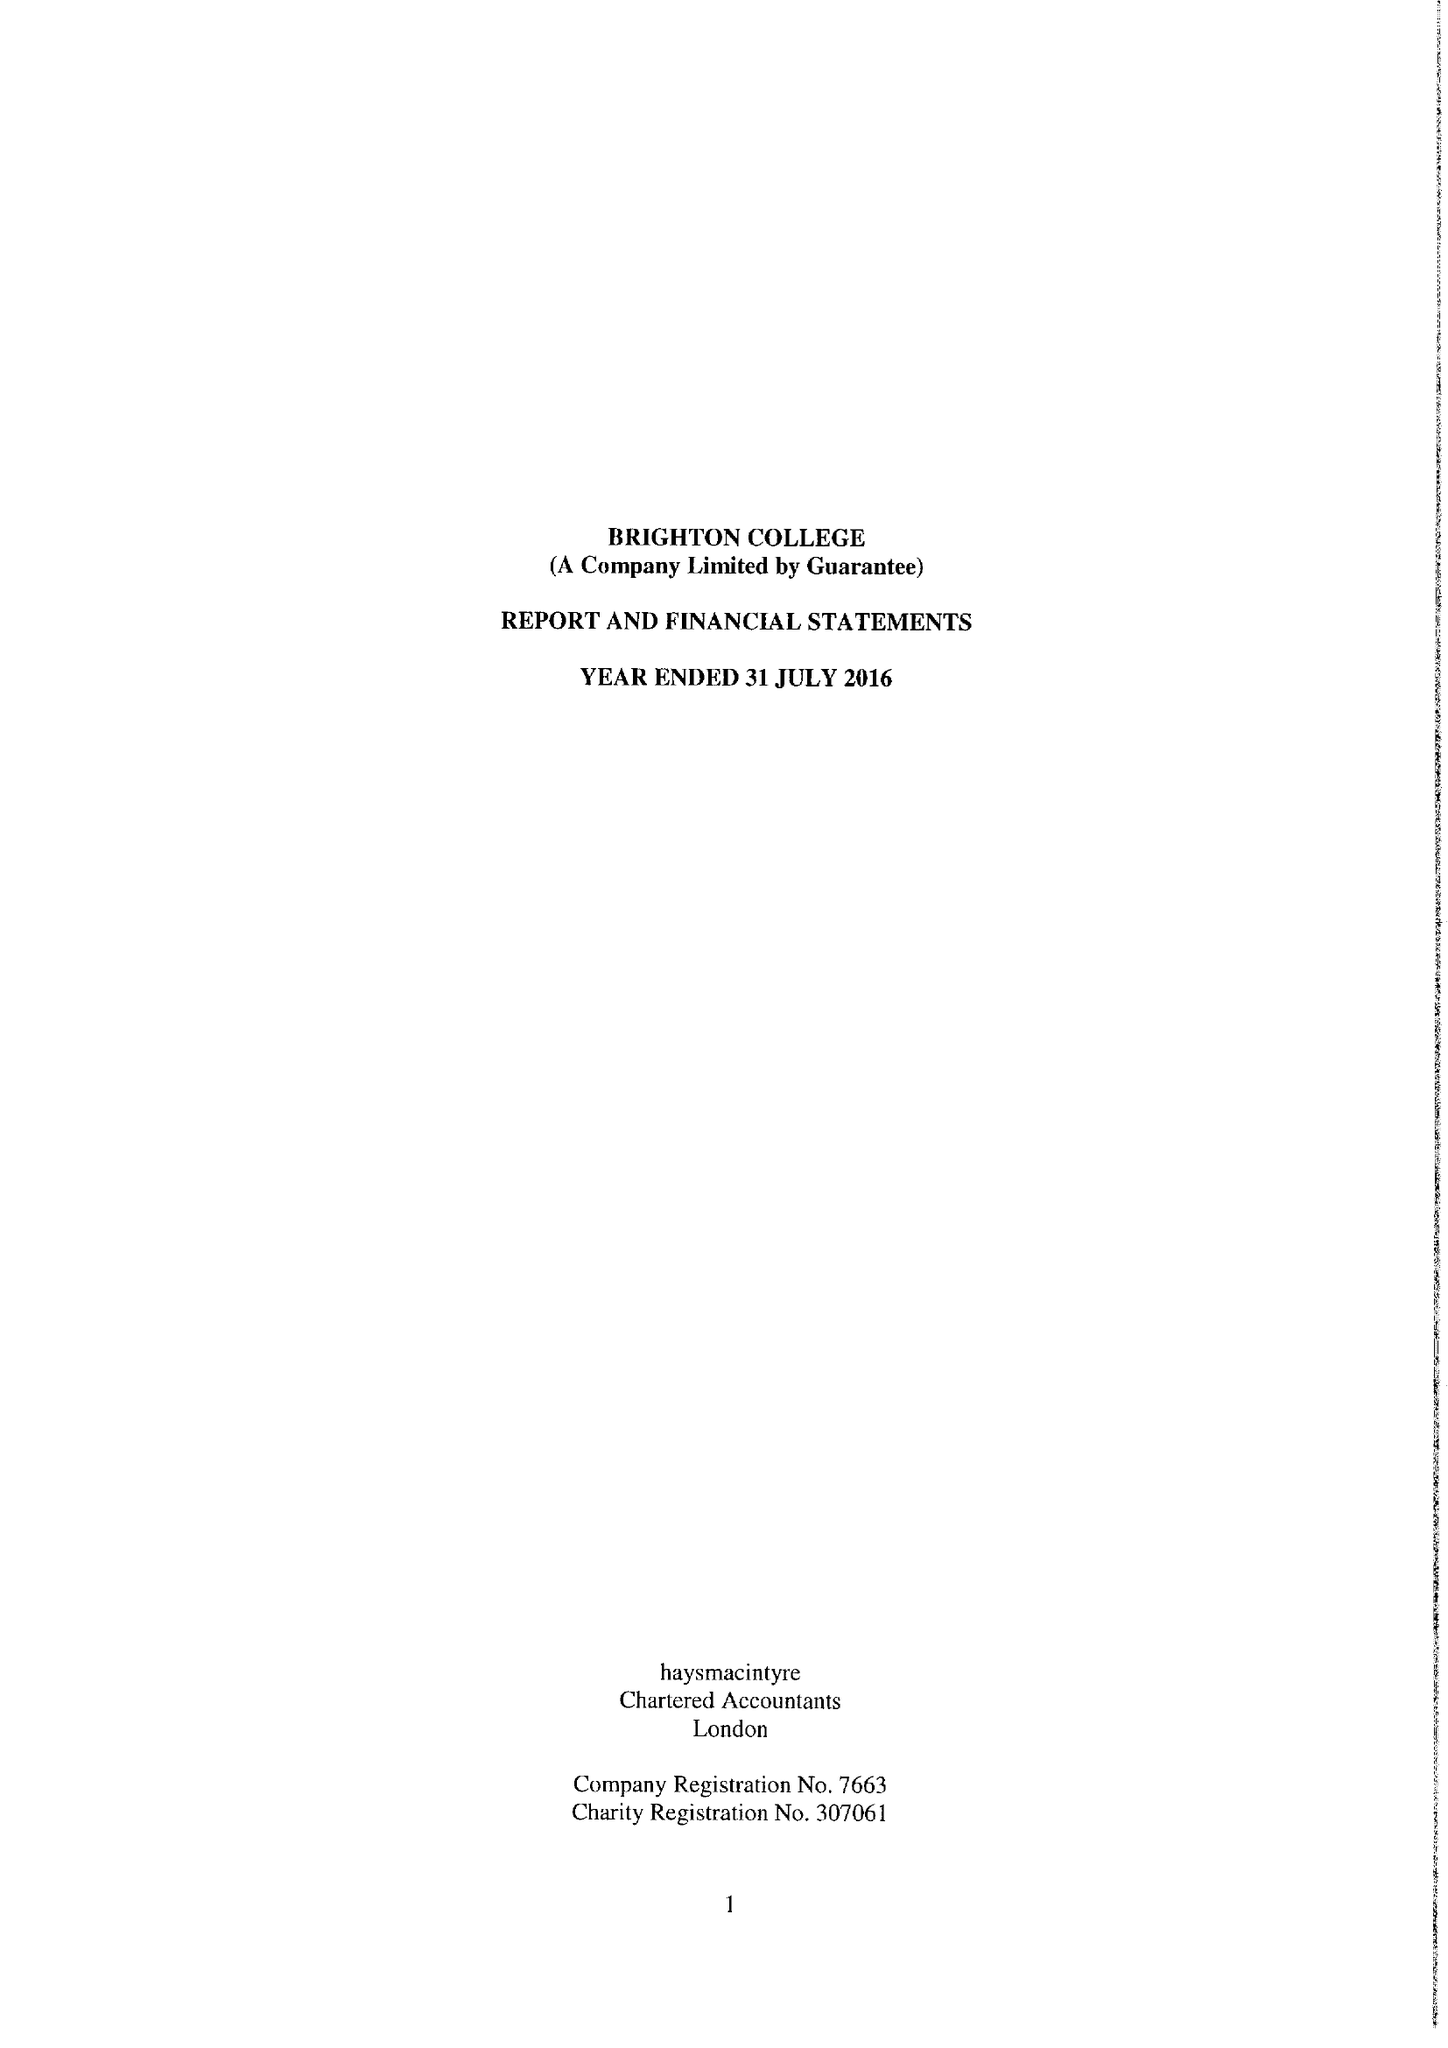What is the value for the charity_name?
Answer the question using a single word or phrase. Brighton College 